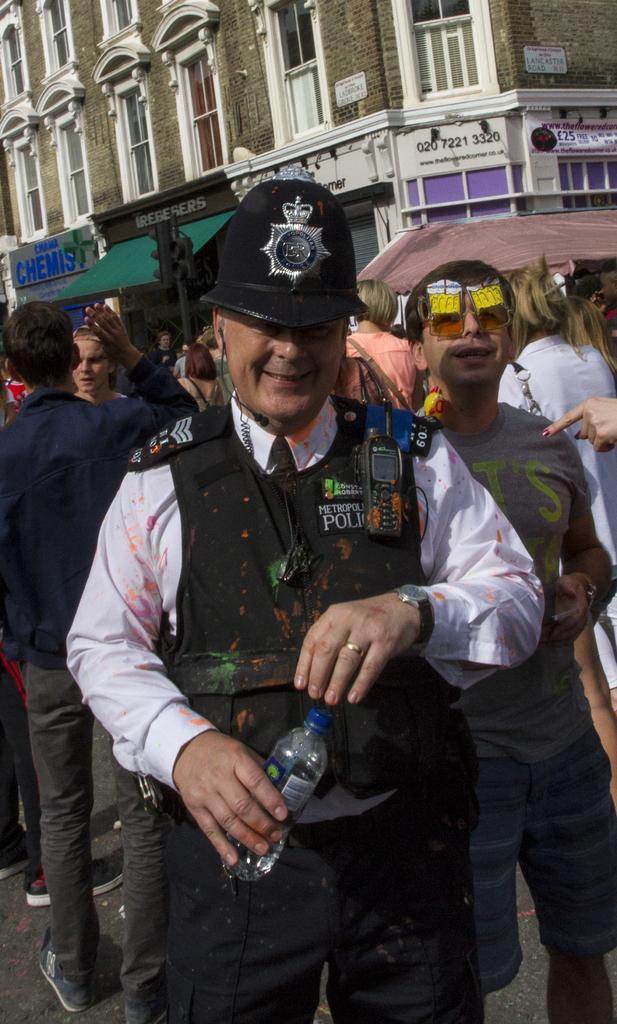What is the man in the image doing? The man is holding a bottle and smiling. What can be seen in the background of the image? There are people and a building in the background of the image. What type of goat can be seen standing on the man's toes in the image? There is no goat present in the image, and the man's toes are not visible. 